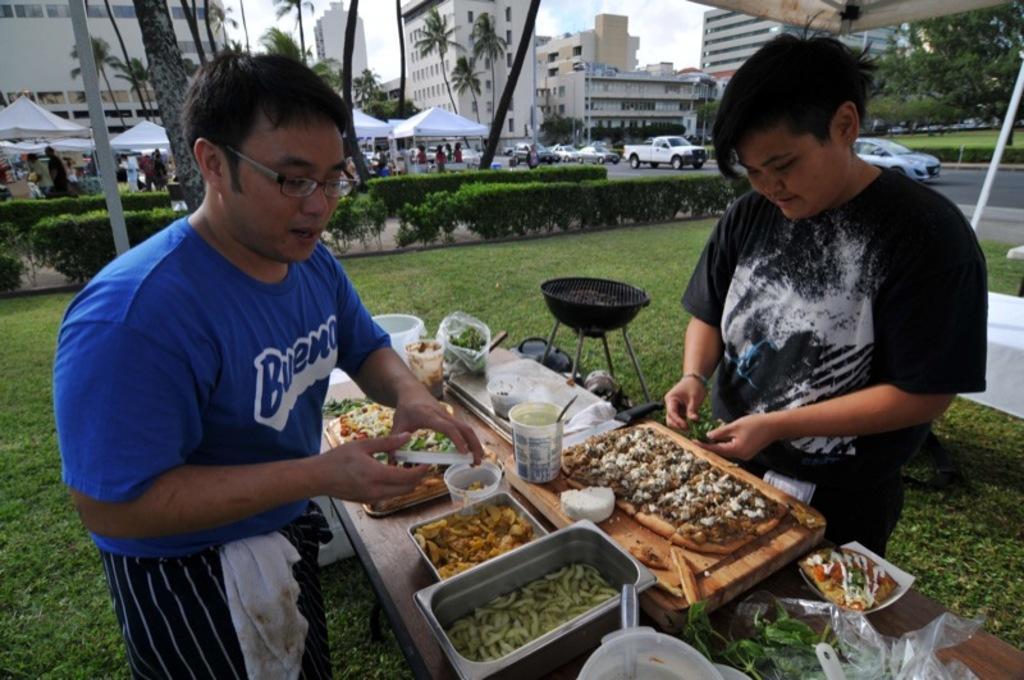Can you describe this image briefly? In the image we can see there are people standing on the ground, the ground is covered with grass and on table there are food items. Beside there is a grilling pan kept. Behind there are vehicles parked on the road and there are buildings and trees at the back. 